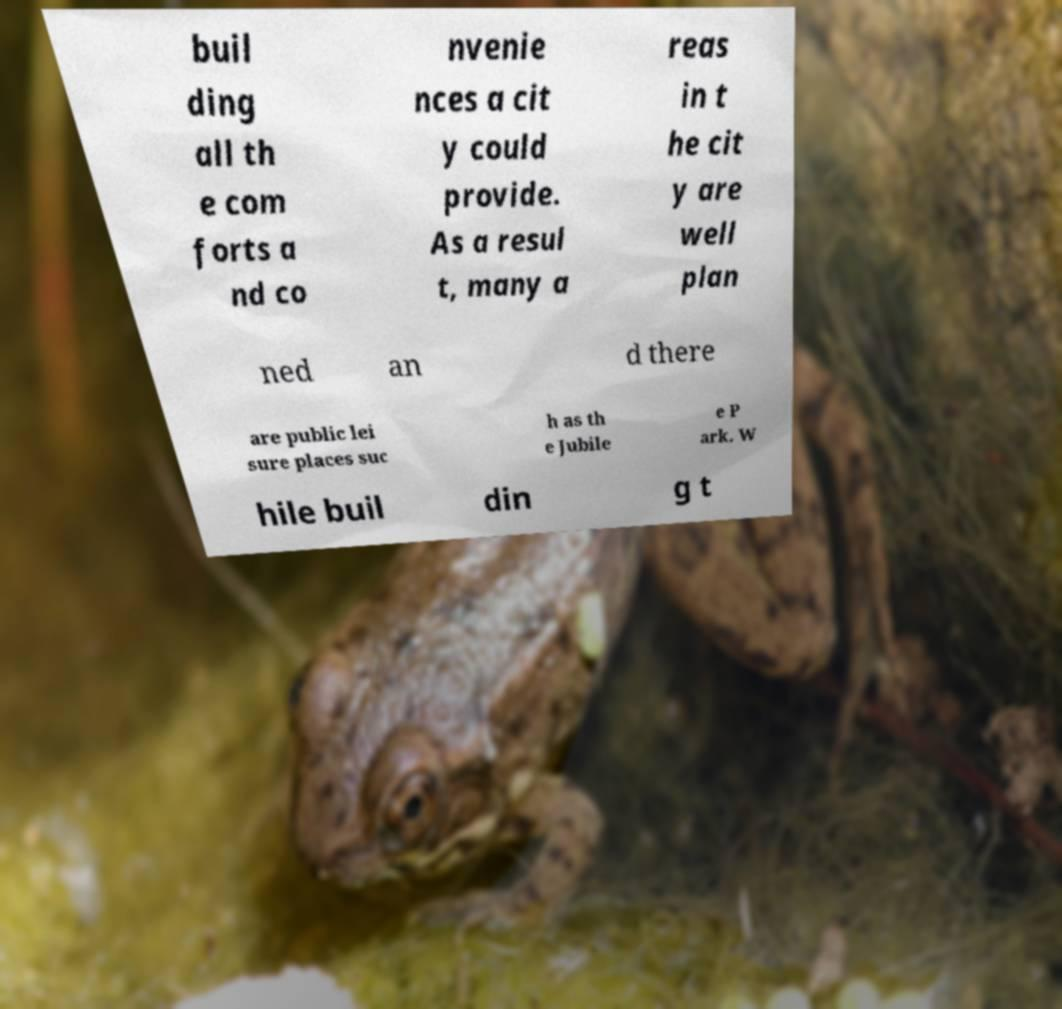Please read and relay the text visible in this image. What does it say? buil ding all th e com forts a nd co nvenie nces a cit y could provide. As a resul t, many a reas in t he cit y are well plan ned an d there are public lei sure places suc h as th e Jubile e P ark. W hile buil din g t 